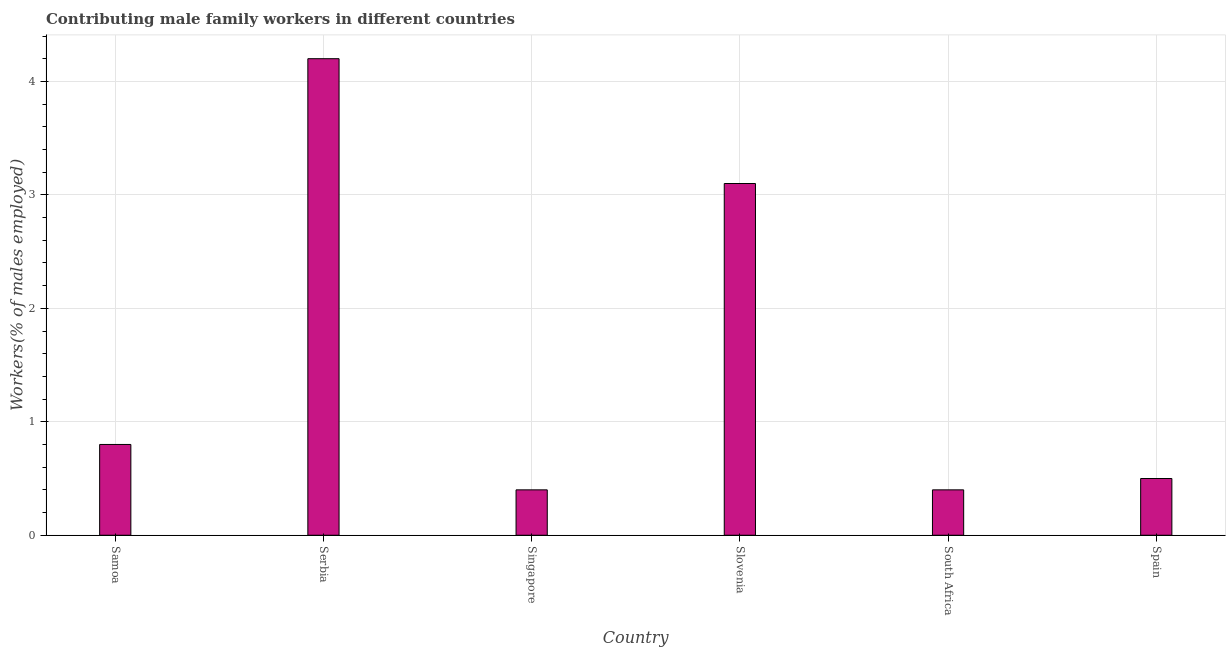Does the graph contain grids?
Your answer should be very brief. Yes. What is the title of the graph?
Provide a short and direct response. Contributing male family workers in different countries. What is the label or title of the Y-axis?
Ensure brevity in your answer.  Workers(% of males employed). What is the contributing male family workers in Serbia?
Offer a terse response. 4.2. Across all countries, what is the maximum contributing male family workers?
Provide a short and direct response. 4.2. Across all countries, what is the minimum contributing male family workers?
Offer a very short reply. 0.4. In which country was the contributing male family workers maximum?
Keep it short and to the point. Serbia. In which country was the contributing male family workers minimum?
Your response must be concise. Singapore. What is the sum of the contributing male family workers?
Provide a short and direct response. 9.4. What is the average contributing male family workers per country?
Ensure brevity in your answer.  1.57. What is the median contributing male family workers?
Your response must be concise. 0.65. In how many countries, is the contributing male family workers greater than 1 %?
Provide a short and direct response. 2. What is the ratio of the contributing male family workers in Serbia to that in Slovenia?
Your answer should be compact. 1.35. Is the difference between the contributing male family workers in Singapore and Spain greater than the difference between any two countries?
Keep it short and to the point. No. What is the difference between the highest and the second highest contributing male family workers?
Your response must be concise. 1.1. What is the difference between the highest and the lowest contributing male family workers?
Offer a very short reply. 3.8. In how many countries, is the contributing male family workers greater than the average contributing male family workers taken over all countries?
Provide a succinct answer. 2. How many bars are there?
Your answer should be compact. 6. Are all the bars in the graph horizontal?
Your answer should be compact. No. How many countries are there in the graph?
Provide a succinct answer. 6. What is the difference between two consecutive major ticks on the Y-axis?
Offer a terse response. 1. Are the values on the major ticks of Y-axis written in scientific E-notation?
Ensure brevity in your answer.  No. What is the Workers(% of males employed) of Samoa?
Keep it short and to the point. 0.8. What is the Workers(% of males employed) in Serbia?
Keep it short and to the point. 4.2. What is the Workers(% of males employed) of Singapore?
Your answer should be very brief. 0.4. What is the Workers(% of males employed) of Slovenia?
Provide a succinct answer. 3.1. What is the Workers(% of males employed) in South Africa?
Make the answer very short. 0.4. What is the Workers(% of males employed) of Spain?
Provide a succinct answer. 0.5. What is the difference between the Workers(% of males employed) in Samoa and Serbia?
Give a very brief answer. -3.4. What is the difference between the Workers(% of males employed) in Samoa and Singapore?
Provide a short and direct response. 0.4. What is the difference between the Workers(% of males employed) in Serbia and Slovenia?
Ensure brevity in your answer.  1.1. What is the difference between the Workers(% of males employed) in Serbia and South Africa?
Ensure brevity in your answer.  3.8. What is the difference between the Workers(% of males employed) in Singapore and South Africa?
Ensure brevity in your answer.  0. What is the difference between the Workers(% of males employed) in Singapore and Spain?
Your answer should be very brief. -0.1. What is the difference between the Workers(% of males employed) in Slovenia and South Africa?
Keep it short and to the point. 2.7. What is the difference between the Workers(% of males employed) in Slovenia and Spain?
Your answer should be very brief. 2.6. What is the difference between the Workers(% of males employed) in South Africa and Spain?
Offer a terse response. -0.1. What is the ratio of the Workers(% of males employed) in Samoa to that in Serbia?
Your answer should be very brief. 0.19. What is the ratio of the Workers(% of males employed) in Samoa to that in Singapore?
Your response must be concise. 2. What is the ratio of the Workers(% of males employed) in Samoa to that in Slovenia?
Provide a short and direct response. 0.26. What is the ratio of the Workers(% of males employed) in Serbia to that in Slovenia?
Ensure brevity in your answer.  1.35. What is the ratio of the Workers(% of males employed) in Serbia to that in South Africa?
Make the answer very short. 10.5. What is the ratio of the Workers(% of males employed) in Singapore to that in Slovenia?
Offer a terse response. 0.13. What is the ratio of the Workers(% of males employed) in Singapore to that in South Africa?
Provide a short and direct response. 1. What is the ratio of the Workers(% of males employed) in Singapore to that in Spain?
Your answer should be compact. 0.8. What is the ratio of the Workers(% of males employed) in Slovenia to that in South Africa?
Your response must be concise. 7.75. 